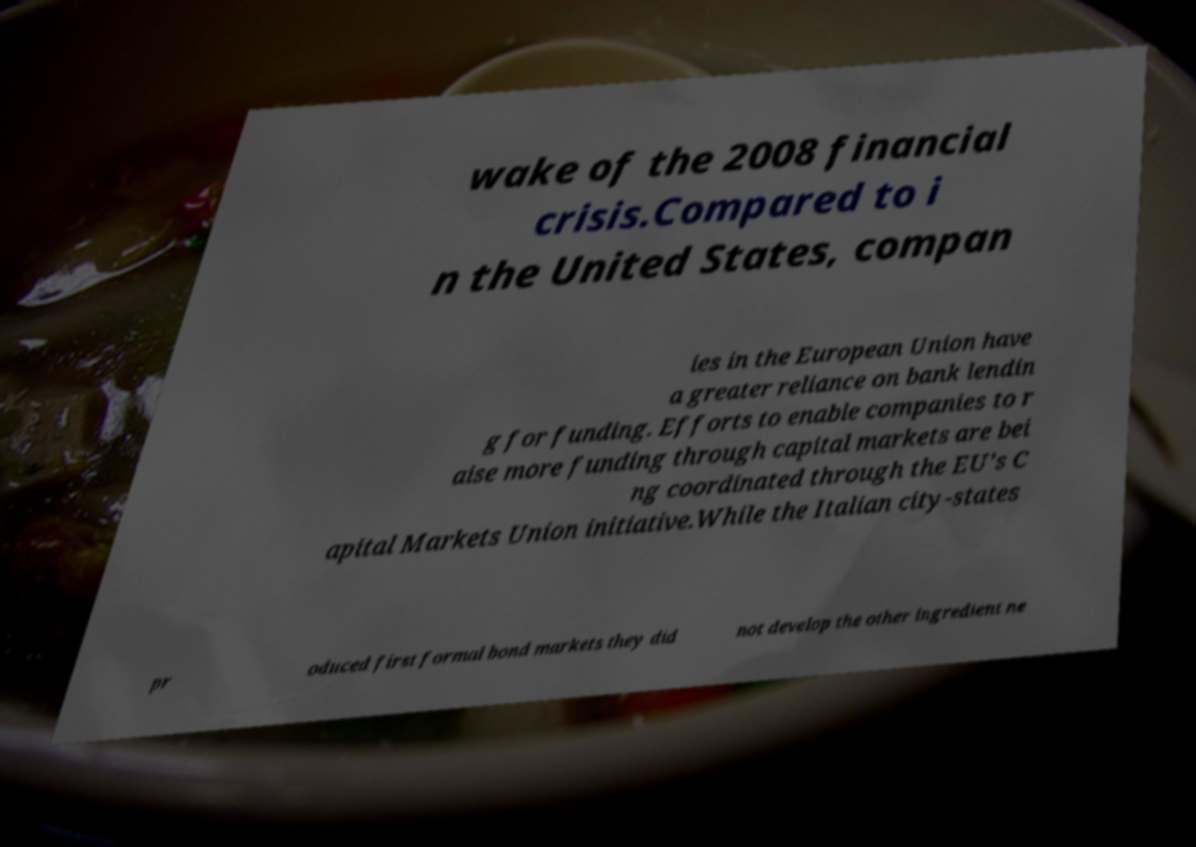What messages or text are displayed in this image? I need them in a readable, typed format. wake of the 2008 financial crisis.Compared to i n the United States, compan ies in the European Union have a greater reliance on bank lendin g for funding. Efforts to enable companies to r aise more funding through capital markets are bei ng coordinated through the EU's C apital Markets Union initiative.While the Italian city-states pr oduced first formal bond markets they did not develop the other ingredient ne 